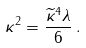Convert formula to latex. <formula><loc_0><loc_0><loc_500><loc_500>\kappa ^ { 2 } = \frac { \widetilde { \kappa } ^ { 4 } \lambda } { 6 } \, .</formula> 